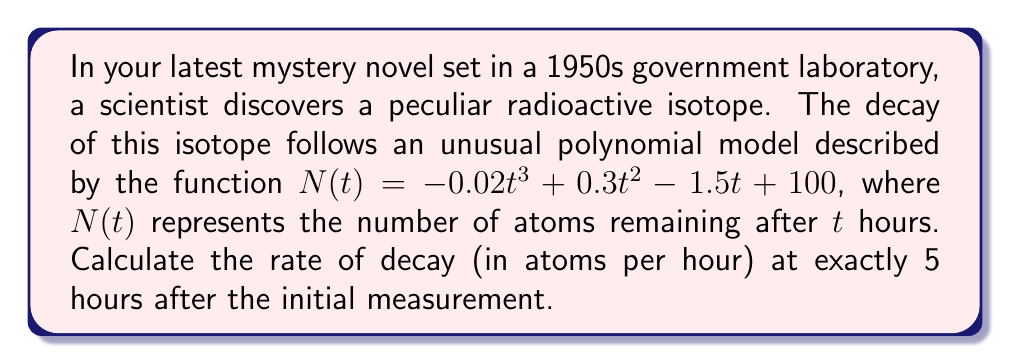Give your solution to this math problem. To solve this problem, we need to follow these steps:

1) The rate of decay is represented by the negative of the derivative of $N(t)$ with respect to $t$. This is because the derivative gives us the rate of change, and we want the rate of decrease.

2) Let's find the derivative of $N(t)$:
   $$\frac{d}{dt}N(t) = -0.06t^2 + 0.6t - 1.5$$

3) The rate of decay is the negative of this:
   $$\text{Rate of decay} = -\frac{d}{dt}N(t) = 0.06t^2 - 0.6t + 1.5$$

4) We need to evaluate this at $t = 5$ hours:
   $$\text{Rate of decay at } t=5 = 0.06(5)^2 - 0.6(5) + 1.5$$

5) Let's calculate:
   $$0.06(25) - 0.6(5) + 1.5 = 1.5 - 3 + 1.5 = 0$$

Therefore, at exactly 5 hours after the initial measurement, the rate of decay is 0 atoms per hour.
Answer: 0 atoms per hour 